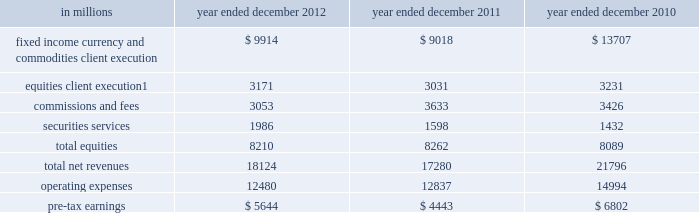Management 2019s discussion and analysis the table below presents the operating results of our institutional client services segment. .
Includes net revenues related to reinsurance of $ 1.08 billion , $ 880 million and $ 827 million for the years ended december 2012 , december 2011 and december 2010 , respectively .
2012 versus 2011 .
Net revenues in institutional client services were $ 18.12 billion for 2012 , 5% ( 5 % ) higher than 2011 .
Net revenues in fixed income , currency and commodities client execution were $ 9.91 billion for 2012 , 10% ( 10 % ) higher than 2011 .
These results reflected strong net revenues in mortgages , which were significantly higher compared with 2011 .
In addition , net revenues in credit products and interest rate products were solid and higher compared with 2011 .
These increases were partially offset by significantly lower net revenues in commodities and slightly lower net revenues in currencies .
Although broad market concerns persisted during 2012 , fixed income , currency and commodities client execution operated in a generally improved environment characterized by tighter credit spreads and less challenging market-making conditions compared with 2011 .
Net revenues in equities were $ 8.21 billion for 2012 , essentially unchanged compared with 2011 .
Net revenues in securities services were significantly higher compared with 2011 , reflecting a gain of approximately $ 500 million on the sale of our hedge fund administration business .
In addition , equities client execution net revenues were higher than 2011 , primarily reflecting significantly higher results in cash products , principally due to increased levels of client activity .
These increases were offset by lower commissions and fees , reflecting lower market volumes .
During 2012 , equities operated in an environment generally characterized by an increase in global equity prices and lower volatility levels .
The net loss attributable to the impact of changes in our own credit spreads on borrowings for which the fair value option was elected was $ 714 million ( $ 433 million and $ 281 million related to fixed income , currency and commodities client execution and equities client execution , respectively ) for 2012 , compared with a net gain of $ 596 million ( $ 399 million and $ 197 million related to fixed income , currency and commodities client execution and equities client execution , respectively ) for 2011 .
During 2012 , institutional client services operated in an environment generally characterized by continued broad market concerns and uncertainties , although positive developments helped to improve market conditions .
These developments included certain central bank actions to ease monetary policy and address funding risks for european financial institutions .
In addition , the u.s .
Economy posted stable to improving economic data , including favorable developments in unemployment and housing .
These improvements resulted in tighter credit spreads , higher global equity prices and lower levels of volatility .
However , concerns about the outlook for the global economy and continued political uncertainty , particularly the political debate in the united states surrounding the fiscal cliff , generally resulted in client risk aversion and lower activity levels .
Also , uncertainty over financial regulatory reform persisted .
If these concerns and uncertainties continue over the long term , net revenues in fixed income , currency and commodities client execution and equities would likely be negatively impacted .
Operating expenses were $ 12.48 billion for 2012 , 3% ( 3 % ) lower than 2011 , primarily due to lower brokerage , clearing , exchange and distribution fees , and lower impairment charges , partially offset by higher net provisions for litigation and regulatory proceedings .
Pre-tax earnings were $ 5.64 billion in 2012 , 27% ( 27 % ) higher than 2011 .
2011 versus 2010 .
Net revenues in institutional client services were $ 17.28 billion for 2011 , 21% ( 21 % ) lower than 2010 .
Net revenues in fixed income , currency and commodities client execution were $ 9.02 billion for 2011 , 34% ( 34 % ) lower than 2010 .
Although activity levels during 2011 were generally consistent with 2010 levels , and results were solid during the first quarter of 2011 , the environment during the remainder of 2011 was characterized by broad market concerns and uncertainty , resulting in volatile markets and significantly wider credit spreads , which contributed to difficult market-making conditions and led to reductions in risk by us and our clients .
As a result of these conditions , net revenues across the franchise were lower , including significant declines in mortgages and credit products , compared with 2010 .
54 goldman sachs 2012 annual report .
Net revenues in institutional client services were what in billions for 2011? 
Computations: (((100 - 5) * 18.12) / 100)
Answer: 17.214. 